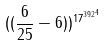<formula> <loc_0><loc_0><loc_500><loc_500>( ( \frac { 6 } { 2 5 } - 6 ) ) ^ { { 1 7 ^ { 3 9 2 } } ^ { 4 } }</formula> 